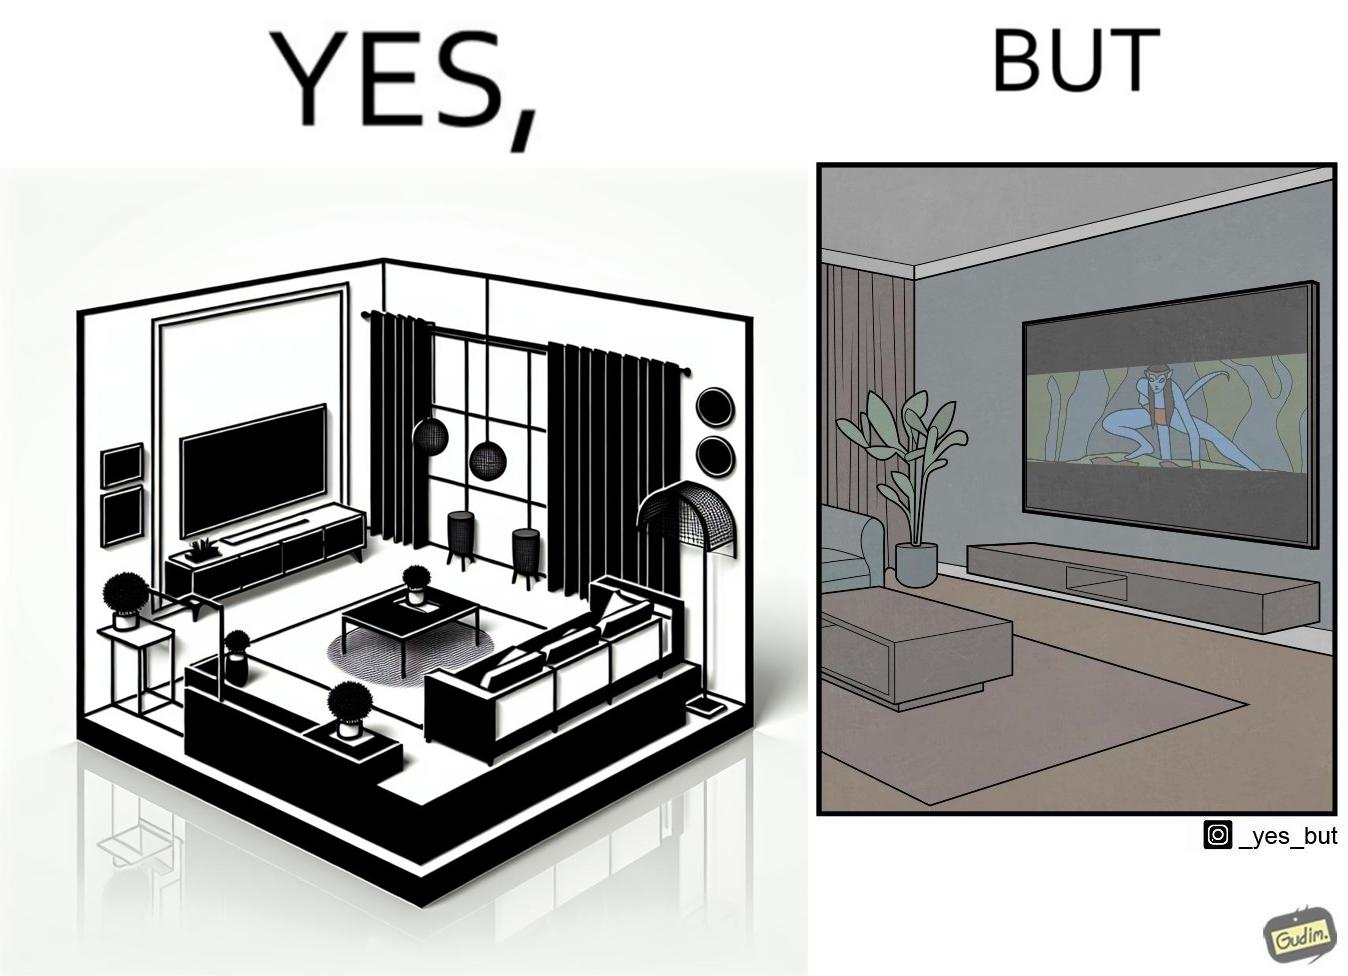What does this image depict? The image is funny because while the room has a big TV with a big screen, the movie being played on it does not use the entire screen. 